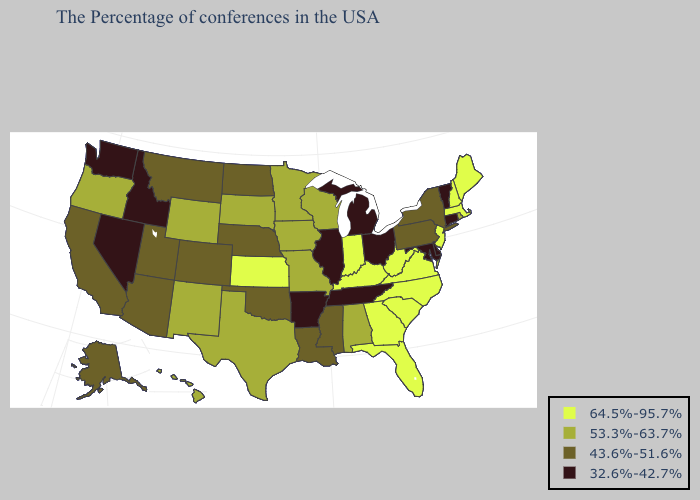Among the states that border Washington , which have the highest value?
Short answer required. Oregon. What is the highest value in the MidWest ?
Answer briefly. 64.5%-95.7%. What is the lowest value in the MidWest?
Keep it brief. 32.6%-42.7%. What is the highest value in states that border Louisiana?
Keep it brief. 53.3%-63.7%. What is the lowest value in states that border Oklahoma?
Give a very brief answer. 32.6%-42.7%. What is the value of Nevada?
Keep it brief. 32.6%-42.7%. Does Texas have the same value as Missouri?
Keep it brief. Yes. Which states have the highest value in the USA?
Concise answer only. Maine, Massachusetts, New Hampshire, New Jersey, Virginia, North Carolina, South Carolina, West Virginia, Florida, Georgia, Kentucky, Indiana, Kansas. Does Minnesota have the same value as Delaware?
Give a very brief answer. No. Name the states that have a value in the range 64.5%-95.7%?
Be succinct. Maine, Massachusetts, New Hampshire, New Jersey, Virginia, North Carolina, South Carolina, West Virginia, Florida, Georgia, Kentucky, Indiana, Kansas. What is the highest value in states that border North Carolina?
Quick response, please. 64.5%-95.7%. Does Texas have the highest value in the USA?
Write a very short answer. No. What is the lowest value in the USA?
Quick response, please. 32.6%-42.7%. What is the highest value in the USA?
Be succinct. 64.5%-95.7%. 